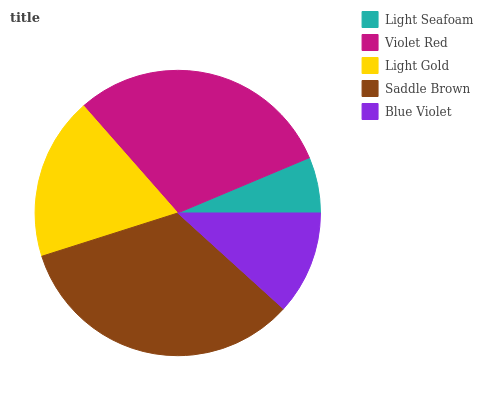Is Light Seafoam the minimum?
Answer yes or no. Yes. Is Saddle Brown the maximum?
Answer yes or no. Yes. Is Violet Red the minimum?
Answer yes or no. No. Is Violet Red the maximum?
Answer yes or no. No. Is Violet Red greater than Light Seafoam?
Answer yes or no. Yes. Is Light Seafoam less than Violet Red?
Answer yes or no. Yes. Is Light Seafoam greater than Violet Red?
Answer yes or no. No. Is Violet Red less than Light Seafoam?
Answer yes or no. No. Is Light Gold the high median?
Answer yes or no. Yes. Is Light Gold the low median?
Answer yes or no. Yes. Is Violet Red the high median?
Answer yes or no. No. Is Violet Red the low median?
Answer yes or no. No. 